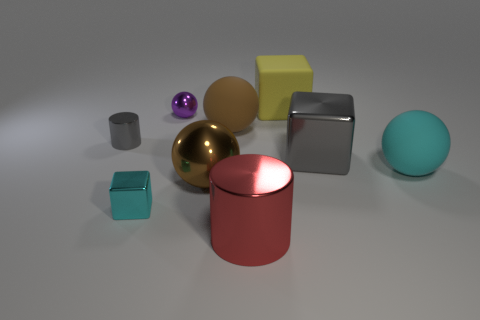Is the number of cyan metal cubes that are to the left of the big cyan rubber sphere less than the number of rubber things?
Provide a succinct answer. Yes. There is a small metallic object in front of the big rubber object that is in front of the cylinder that is left of the tiny ball; what is its shape?
Ensure brevity in your answer.  Cube. What is the size of the yellow cube right of the large red cylinder?
Your answer should be very brief. Large. There is a brown metal thing that is the same size as the red cylinder; what is its shape?
Keep it short and to the point. Sphere. How many objects are either large cyan blocks or cyan things right of the large gray shiny block?
Offer a very short reply. 1. There is a big brown sphere behind the cylinder that is behind the tiny metal cube; how many rubber objects are behind it?
Make the answer very short. 1. There is a big cube that is the same material as the cyan ball; what is its color?
Ensure brevity in your answer.  Yellow. There is a cyan thing on the left side of the brown matte thing; does it have the same size as the big cyan sphere?
Offer a terse response. No. What number of things are either tiny gray shiny objects or yellow rubber cylinders?
Keep it short and to the point. 1. There is a big sphere that is to the right of the big shiny object that is behind the brown thing in front of the gray cube; what is its material?
Your response must be concise. Rubber. 